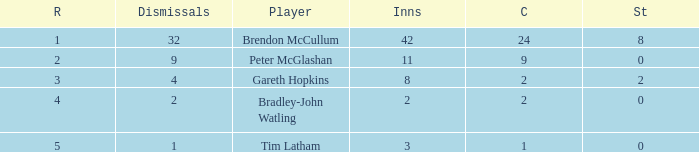How many stumpings did the player Tim Latham have? 0.0. 